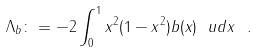Convert formula to latex. <formula><loc_0><loc_0><loc_500><loc_500>\Lambda _ { b } \colon = - 2 \int _ { 0 } ^ { 1 } x ^ { 2 } ( 1 - x ^ { 2 } ) b ( x ) \ u d x \ .</formula> 